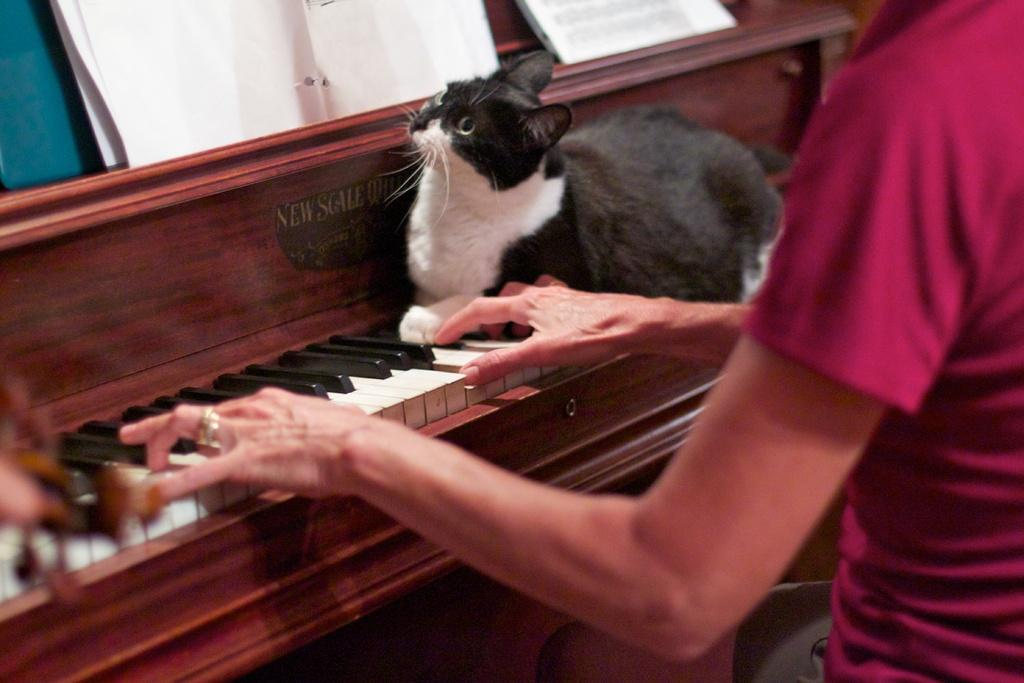Who or what is the main subject in the image? There is a person in the image. What is the person doing in the image? The person is sitting in front of a piano. Are there any other living beings present in the image? Yes, there is a cat on the piano. What country is the person judging in the image? There is no indication of a country or any judging activity in the image. 